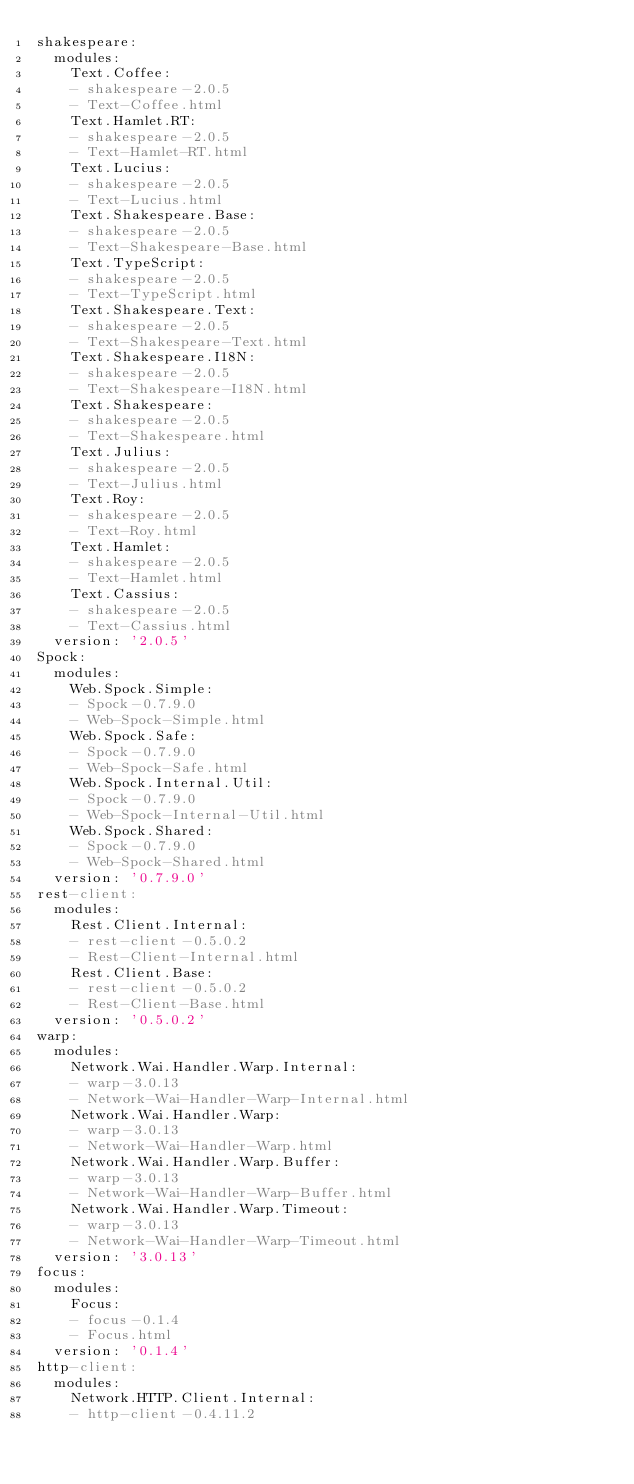Convert code to text. <code><loc_0><loc_0><loc_500><loc_500><_YAML_>shakespeare:
  modules:
    Text.Coffee:
    - shakespeare-2.0.5
    - Text-Coffee.html
    Text.Hamlet.RT:
    - shakespeare-2.0.5
    - Text-Hamlet-RT.html
    Text.Lucius:
    - shakespeare-2.0.5
    - Text-Lucius.html
    Text.Shakespeare.Base:
    - shakespeare-2.0.5
    - Text-Shakespeare-Base.html
    Text.TypeScript:
    - shakespeare-2.0.5
    - Text-TypeScript.html
    Text.Shakespeare.Text:
    - shakespeare-2.0.5
    - Text-Shakespeare-Text.html
    Text.Shakespeare.I18N:
    - shakespeare-2.0.5
    - Text-Shakespeare-I18N.html
    Text.Shakespeare:
    - shakespeare-2.0.5
    - Text-Shakespeare.html
    Text.Julius:
    - shakespeare-2.0.5
    - Text-Julius.html
    Text.Roy:
    - shakespeare-2.0.5
    - Text-Roy.html
    Text.Hamlet:
    - shakespeare-2.0.5
    - Text-Hamlet.html
    Text.Cassius:
    - shakespeare-2.0.5
    - Text-Cassius.html
  version: '2.0.5'
Spock:
  modules:
    Web.Spock.Simple:
    - Spock-0.7.9.0
    - Web-Spock-Simple.html
    Web.Spock.Safe:
    - Spock-0.7.9.0
    - Web-Spock-Safe.html
    Web.Spock.Internal.Util:
    - Spock-0.7.9.0
    - Web-Spock-Internal-Util.html
    Web.Spock.Shared:
    - Spock-0.7.9.0
    - Web-Spock-Shared.html
  version: '0.7.9.0'
rest-client:
  modules:
    Rest.Client.Internal:
    - rest-client-0.5.0.2
    - Rest-Client-Internal.html
    Rest.Client.Base:
    - rest-client-0.5.0.2
    - Rest-Client-Base.html
  version: '0.5.0.2'
warp:
  modules:
    Network.Wai.Handler.Warp.Internal:
    - warp-3.0.13
    - Network-Wai-Handler-Warp-Internal.html
    Network.Wai.Handler.Warp:
    - warp-3.0.13
    - Network-Wai-Handler-Warp.html
    Network.Wai.Handler.Warp.Buffer:
    - warp-3.0.13
    - Network-Wai-Handler-Warp-Buffer.html
    Network.Wai.Handler.Warp.Timeout:
    - warp-3.0.13
    - Network-Wai-Handler-Warp-Timeout.html
  version: '3.0.13'
focus:
  modules:
    Focus:
    - focus-0.1.4
    - Focus.html
  version: '0.1.4'
http-client:
  modules:
    Network.HTTP.Client.Internal:
    - http-client-0.4.11.2</code> 